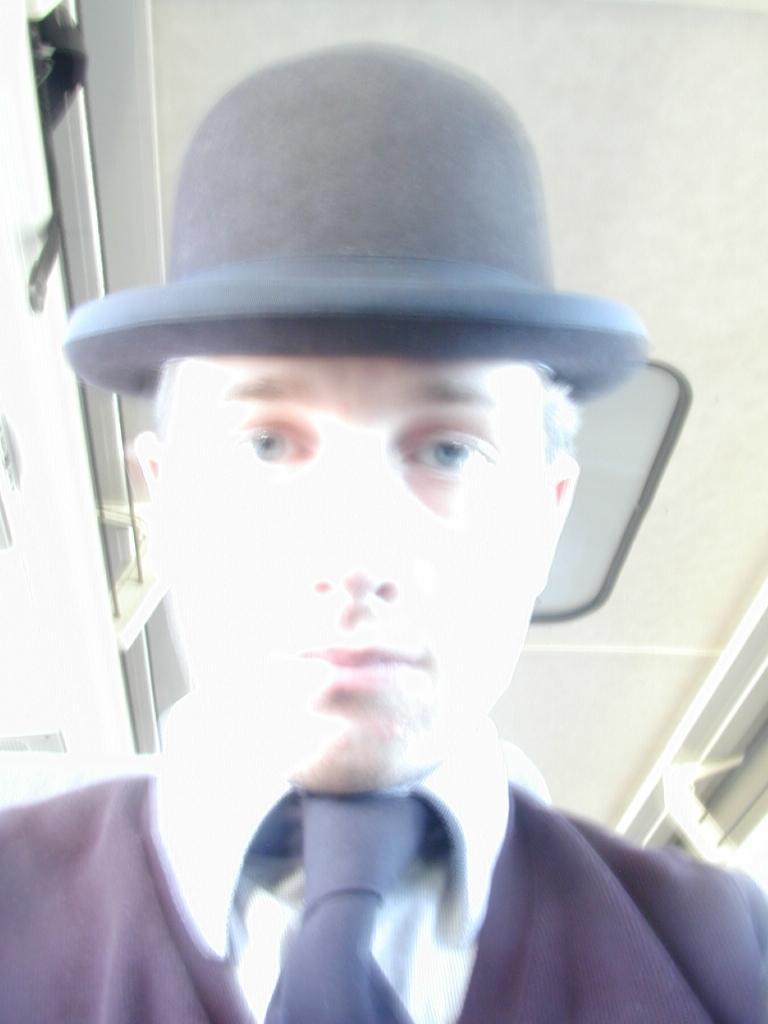In one or two sentences, can you explain what this image depicts? In this image I can see a man. I can see he is wearing a white shirt, a black tie and a black hat. I can also see this image is little bit blurry. 